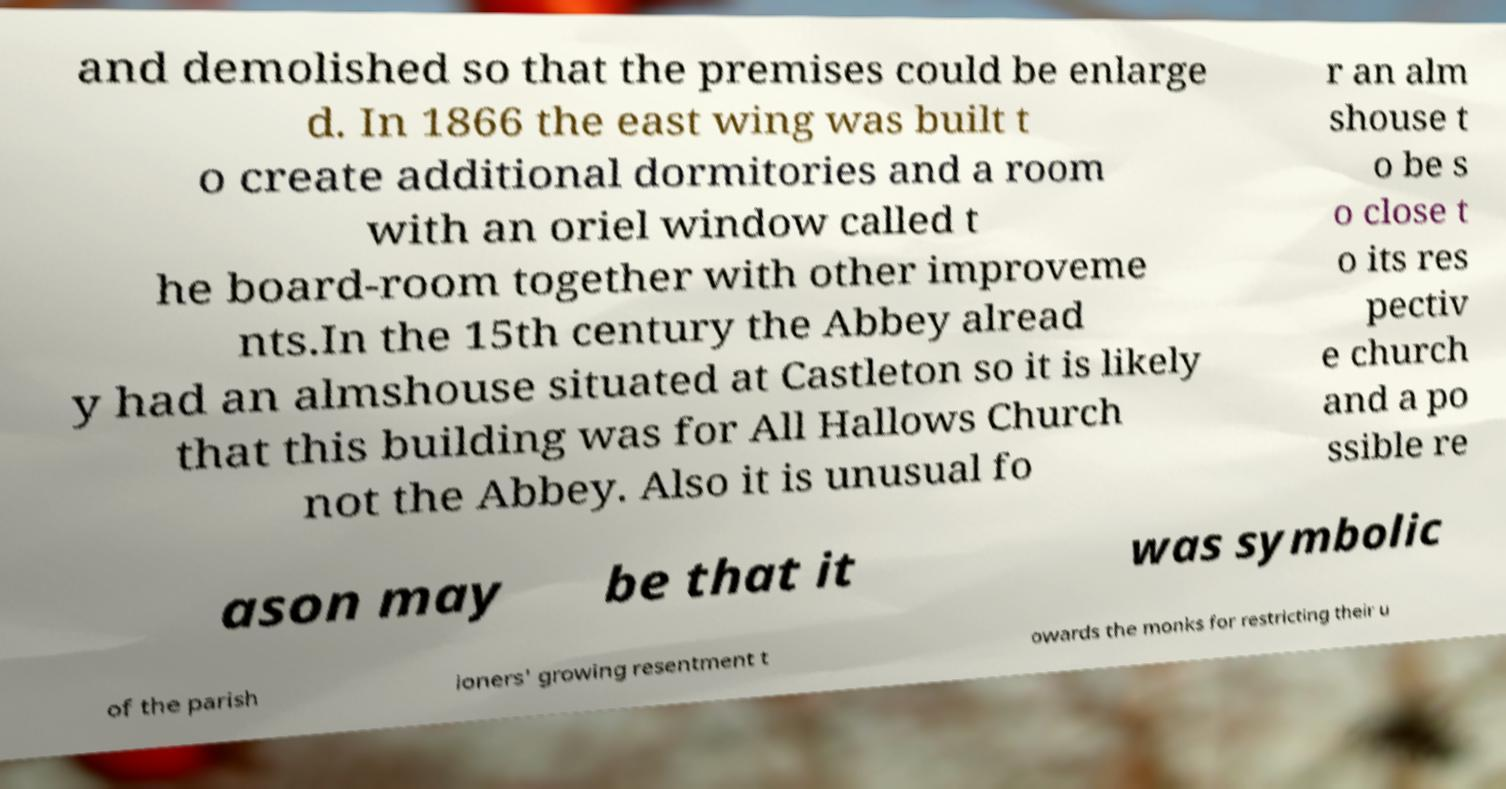Could you extract and type out the text from this image? and demolished so that the premises could be enlarge d. In 1866 the east wing was built t o create additional dormitories and a room with an oriel window called t he board-room together with other improveme nts.In the 15th century the Abbey alread y had an almshouse situated at Castleton so it is likely that this building was for All Hallows Church not the Abbey. Also it is unusual fo r an alm shouse t o be s o close t o its res pectiv e church and a po ssible re ason may be that it was symbolic of the parish ioners' growing resentment t owards the monks for restricting their u 